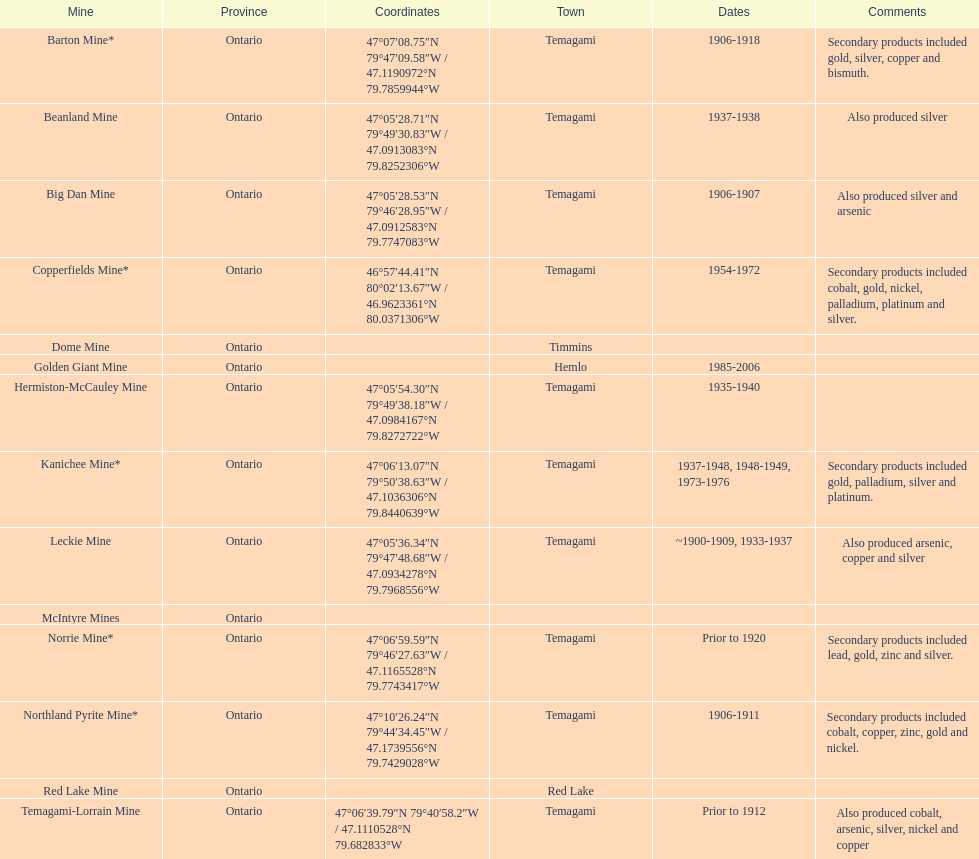Which mine is situated in the town of timmins? Dome Mine. 